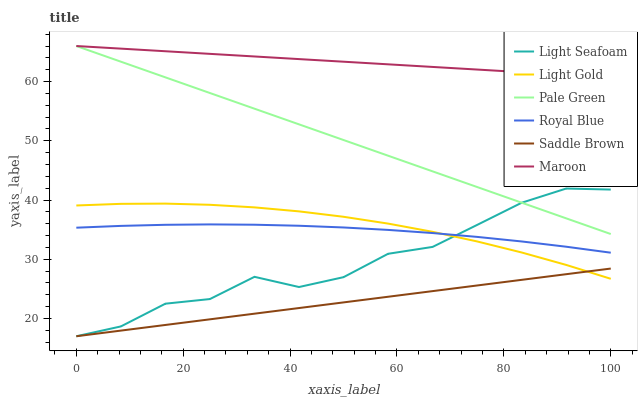Does Saddle Brown have the minimum area under the curve?
Answer yes or no. Yes. Does Maroon have the maximum area under the curve?
Answer yes or no. Yes. Does Royal Blue have the minimum area under the curve?
Answer yes or no. No. Does Royal Blue have the maximum area under the curve?
Answer yes or no. No. Is Saddle Brown the smoothest?
Answer yes or no. Yes. Is Light Seafoam the roughest?
Answer yes or no. Yes. Is Royal Blue the smoothest?
Answer yes or no. No. Is Royal Blue the roughest?
Answer yes or no. No. Does Light Seafoam have the lowest value?
Answer yes or no. Yes. Does Royal Blue have the lowest value?
Answer yes or no. No. Does Pale Green have the highest value?
Answer yes or no. Yes. Does Royal Blue have the highest value?
Answer yes or no. No. Is Light Gold less than Maroon?
Answer yes or no. Yes. Is Maroon greater than Light Seafoam?
Answer yes or no. Yes. Does Saddle Brown intersect Light Gold?
Answer yes or no. Yes. Is Saddle Brown less than Light Gold?
Answer yes or no. No. Is Saddle Brown greater than Light Gold?
Answer yes or no. No. Does Light Gold intersect Maroon?
Answer yes or no. No. 